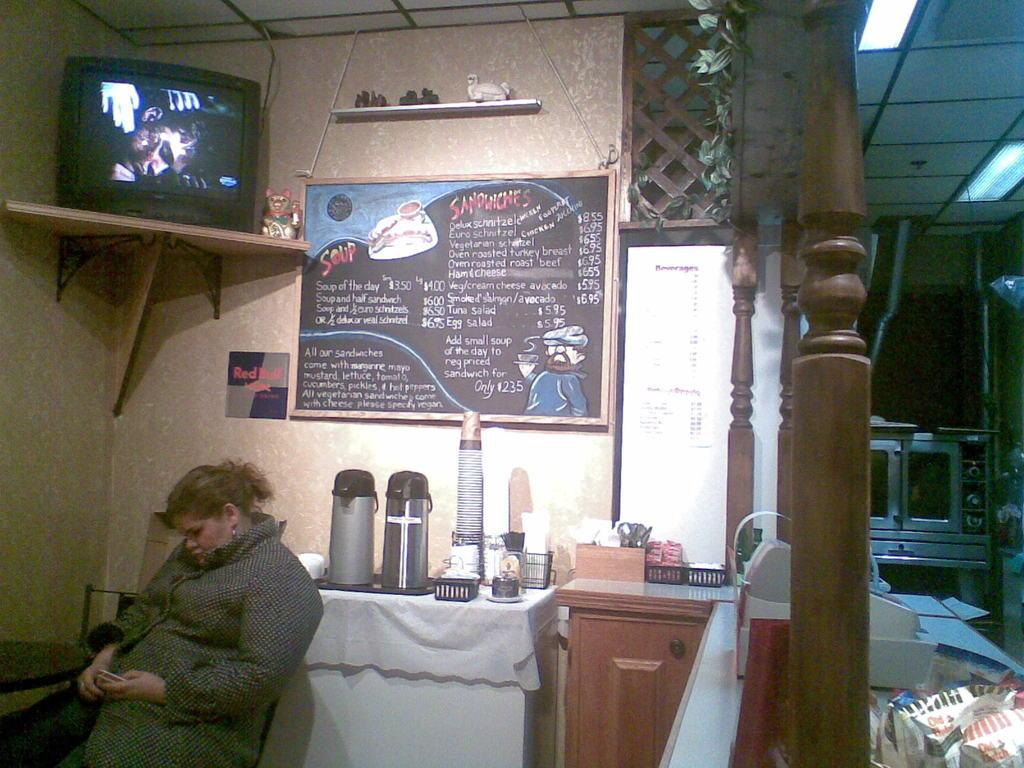What is the woman in the image doing? The woman is sitting in the image. What can be seen on the board in the image? There is a menu on the board in the image. What is placed on top of the board in the image? There is a TV on top of the board in the image. How many clovers are visible on the menu in the image? There are no clovers present on the menu in the image. What type of expansion is shown on the TV in the image? There is no expansion shown on the TV in the image; it is simply a TV placed on top of the board. 